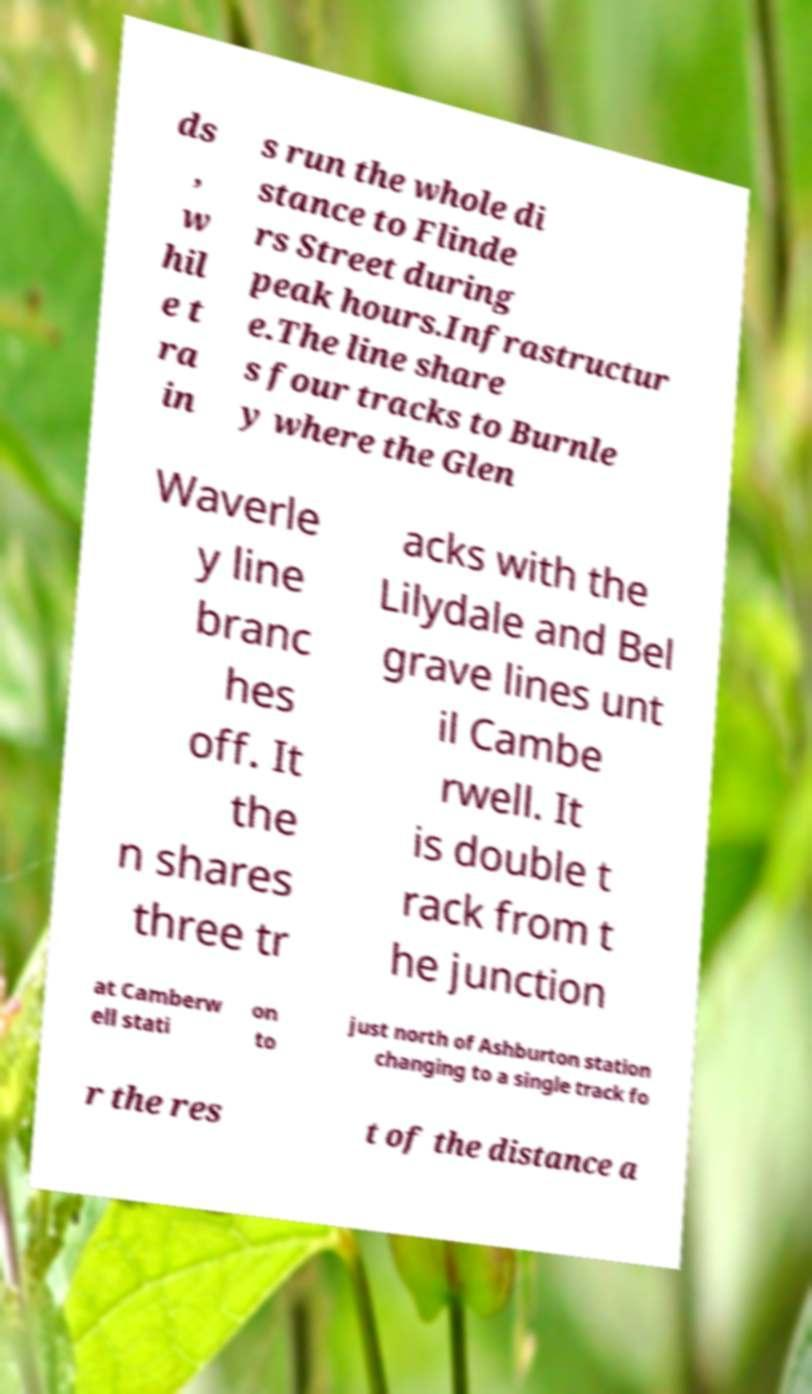There's text embedded in this image that I need extracted. Can you transcribe it verbatim? ds , w hil e t ra in s run the whole di stance to Flinde rs Street during peak hours.Infrastructur e.The line share s four tracks to Burnle y where the Glen Waverle y line branc hes off. It the n shares three tr acks with the Lilydale and Bel grave lines unt il Cambe rwell. It is double t rack from t he junction at Camberw ell stati on to just north of Ashburton station changing to a single track fo r the res t of the distance a 